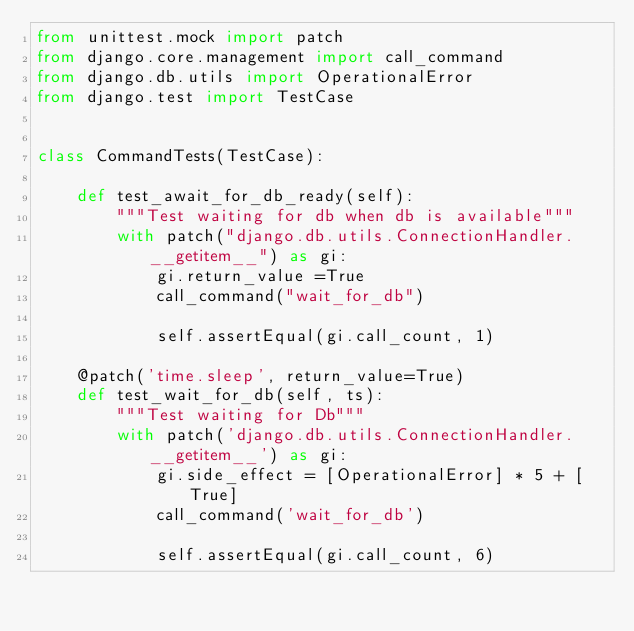<code> <loc_0><loc_0><loc_500><loc_500><_Python_>from unittest.mock import patch
from django.core.management import call_command
from django.db.utils import OperationalError
from django.test import TestCase


class CommandTests(TestCase):

    def test_await_for_db_ready(self):
        """Test waiting for db when db is available"""
        with patch("django.db.utils.ConnectionHandler.__getitem__") as gi:
            gi.return_value =True
            call_command("wait_for_db")

            self.assertEqual(gi.call_count, 1)

    @patch('time.sleep', return_value=True)
    def test_wait_for_db(self, ts):
        """Test waiting for Db"""
        with patch('django.db.utils.ConnectionHandler.__getitem__') as gi:
            gi.side_effect = [OperationalError] * 5 + [True]
            call_command('wait_for_db')

            self.assertEqual(gi.call_count, 6)
</code> 